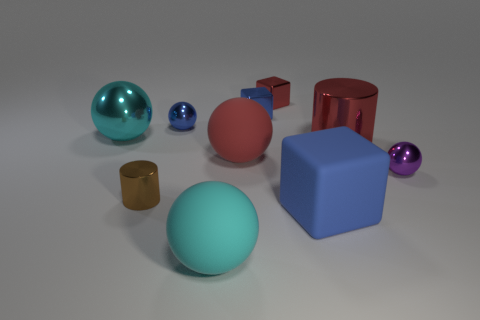How many balls are the same color as the matte block?
Offer a terse response. 1. Does the small metal sphere that is to the left of the red block have the same color as the big block?
Your response must be concise. Yes. What shape is the rubber thing behind the small purple metal object?
Your answer should be compact. Sphere. Is there a big metal object that is behind the cylinder that is right of the red matte sphere?
Your response must be concise. Yes. What number of cylinders have the same material as the purple object?
Your answer should be compact. 2. There is a ball right of the red object behind the metal cube left of the small red metal block; how big is it?
Offer a very short reply. Small. There is a rubber block; how many blue objects are left of it?
Offer a very short reply. 2. Are there more big red rubber cylinders than tiny brown shiny cylinders?
Keep it short and to the point. No. The object that is the same color as the large metal ball is what size?
Keep it short and to the point. Large. What size is the ball that is on the left side of the large metallic cylinder and on the right side of the cyan rubber sphere?
Ensure brevity in your answer.  Large. 